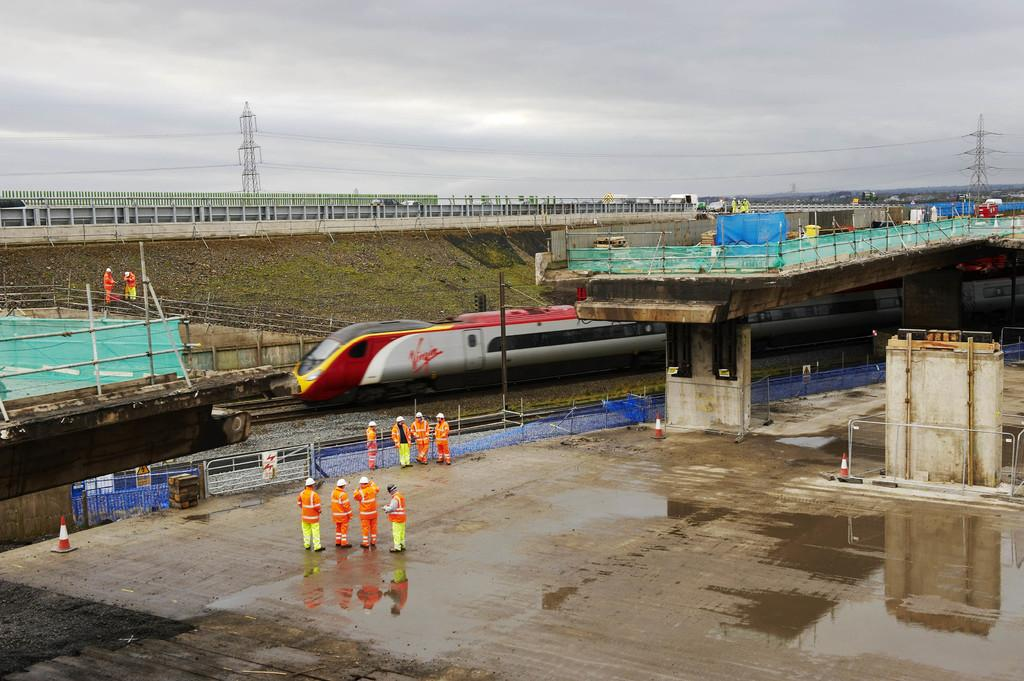<image>
Summarize the visual content of the image. Some workers are standing on wet pavement at a construction site near railroad tracks with a Virgin train. 